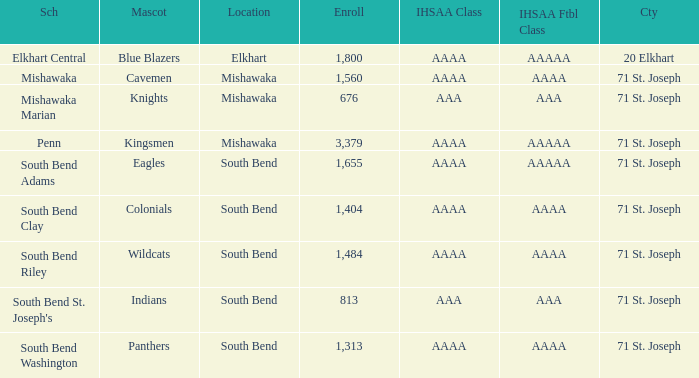What location has kingsmen as the mascot? Mishawaka. 